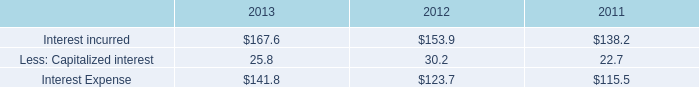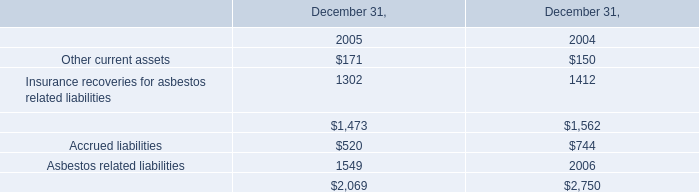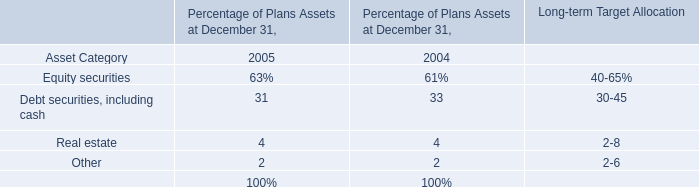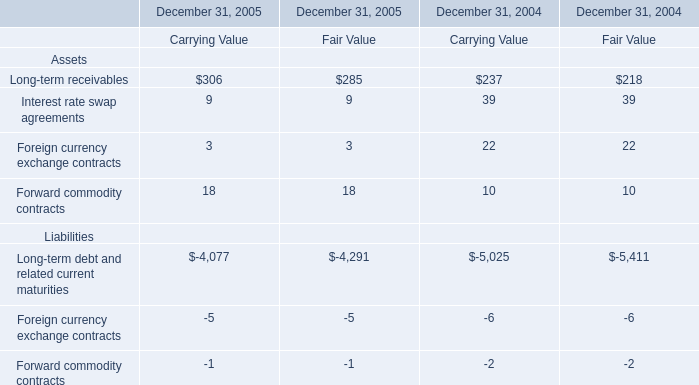what was the percentual increase of other income due to favorable foreign exchange and reimbursements in 2011? 
Computations: (5.4 / 47.1)
Answer: 0.11465. 